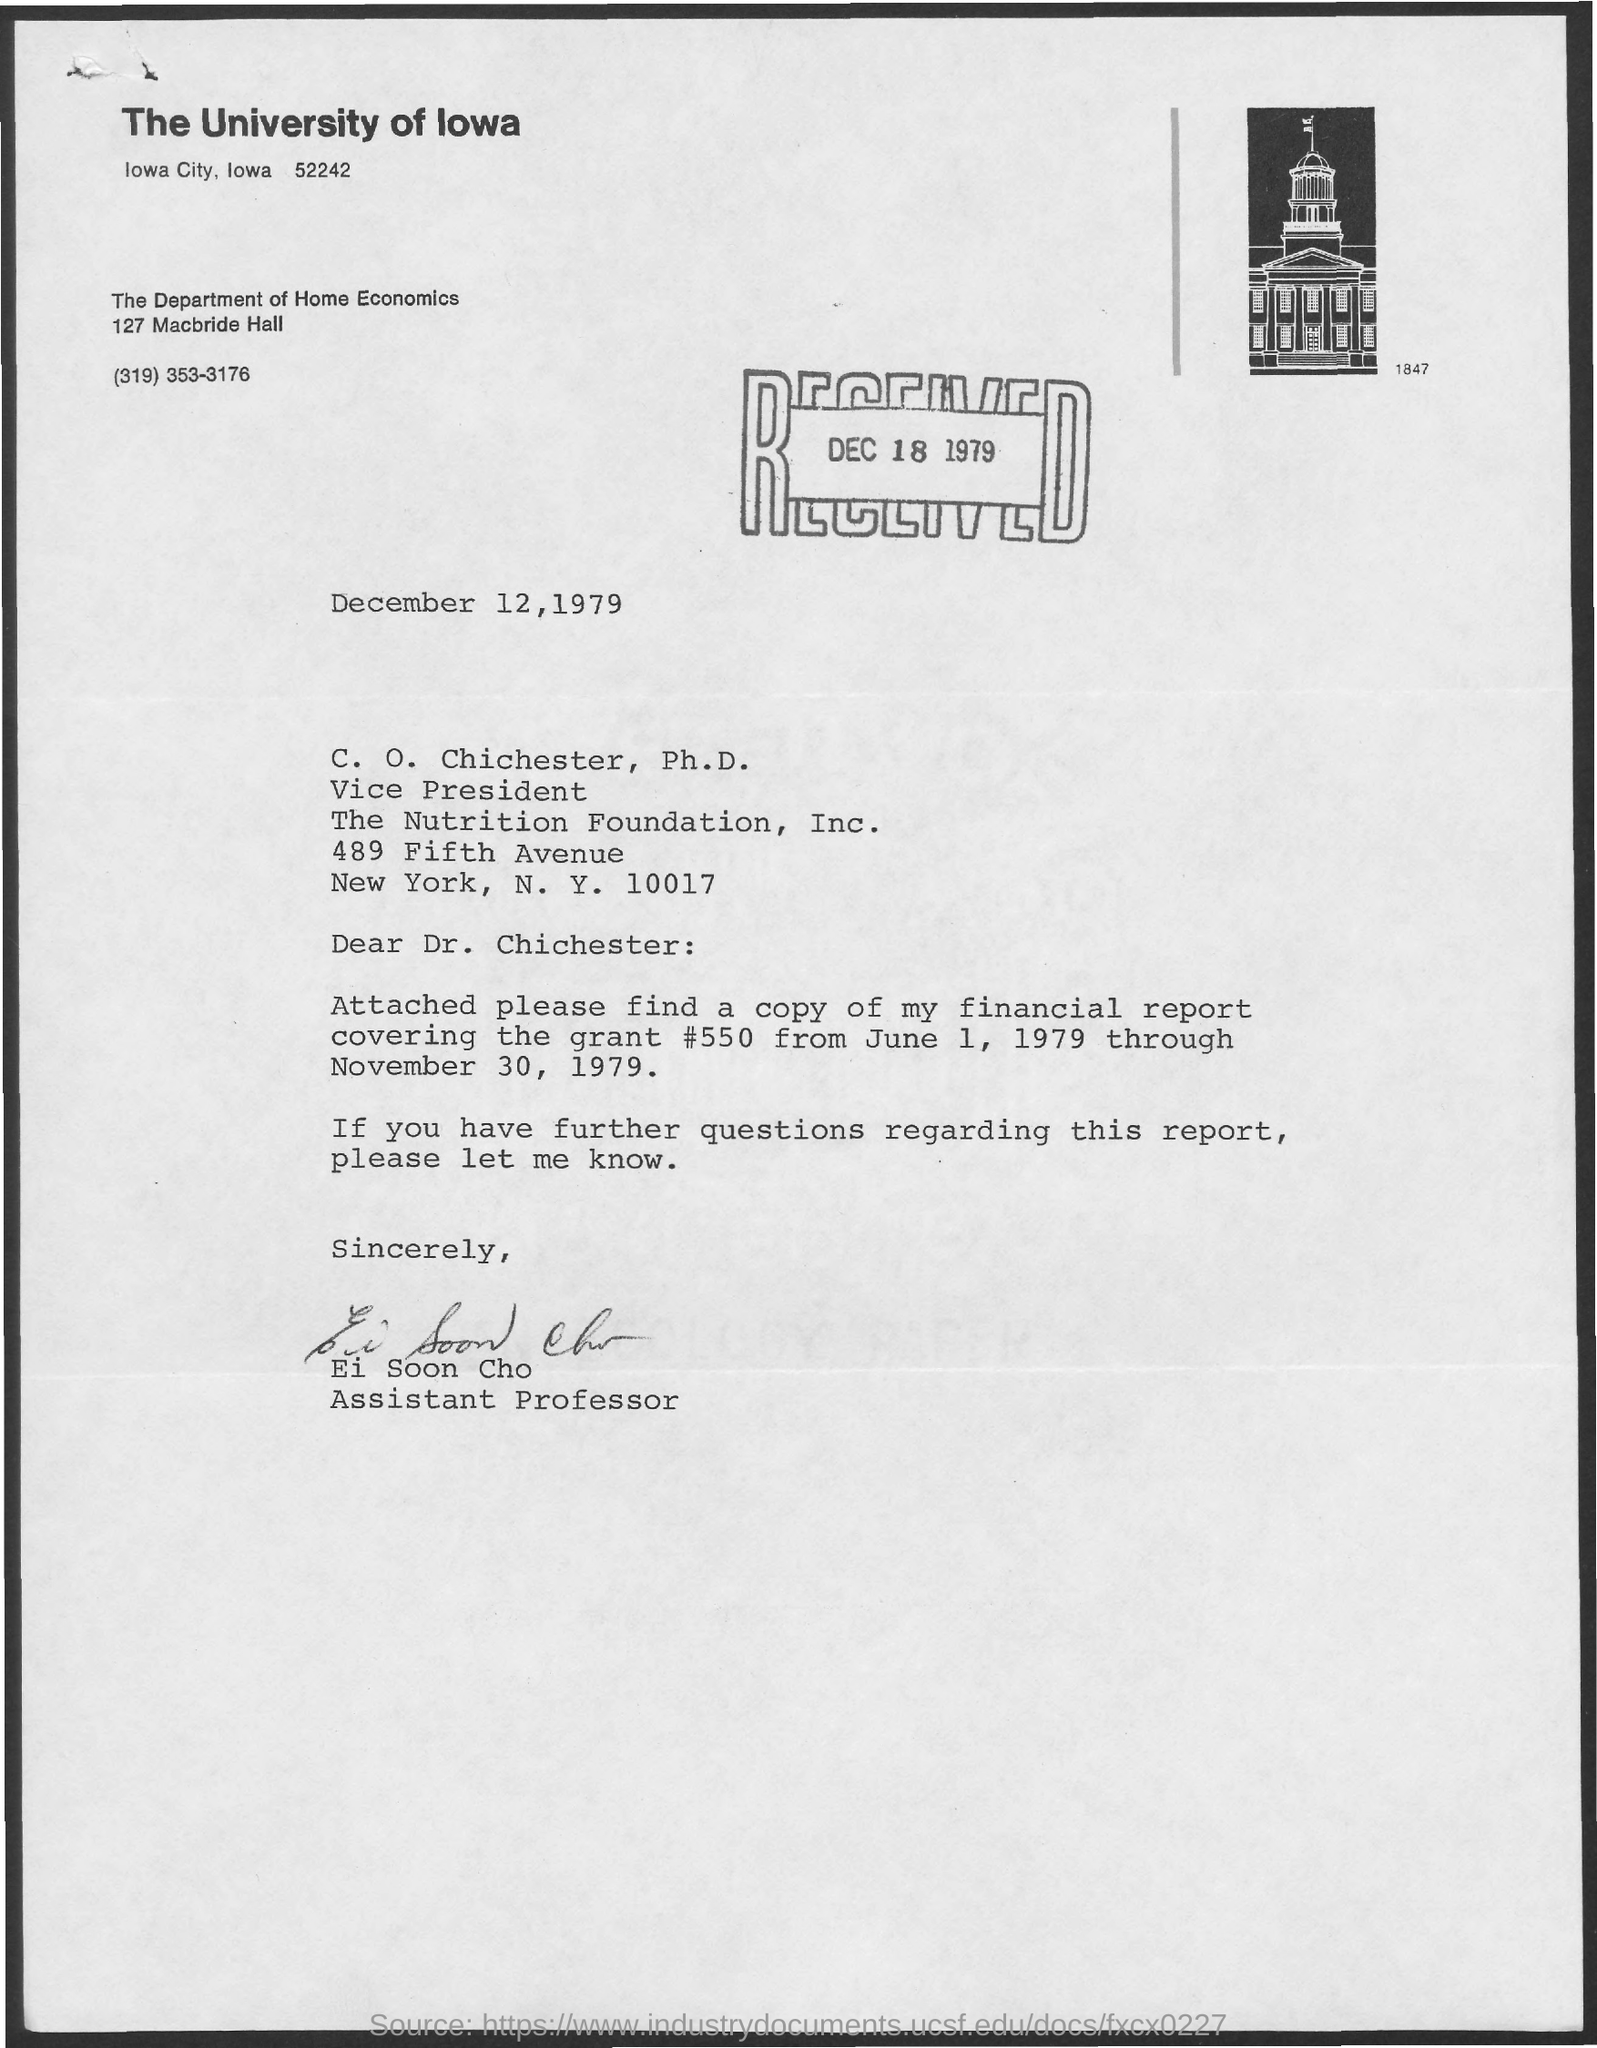When is it Received?
Provide a short and direct response. DEC 18 1979. To Whom is this letter addressed to?
Your response must be concise. C. O. Chichester, Ph.D. Who is this letter from?
Offer a terse response. Ei Soon Cho. 